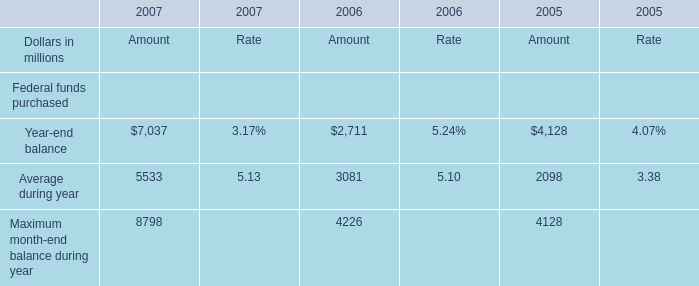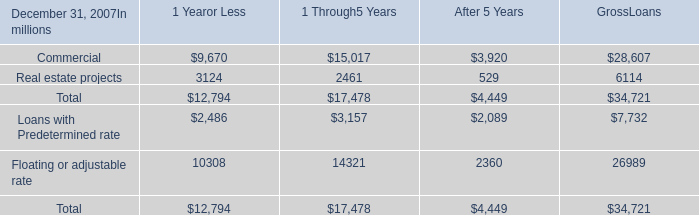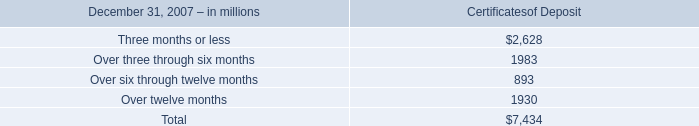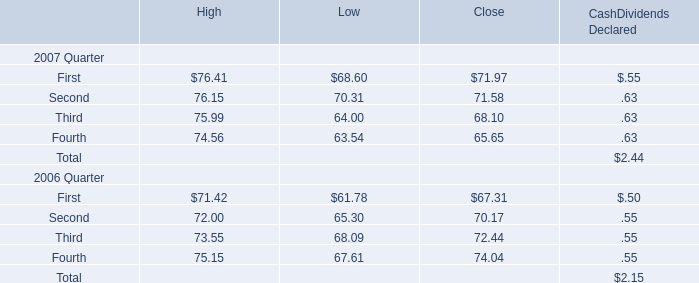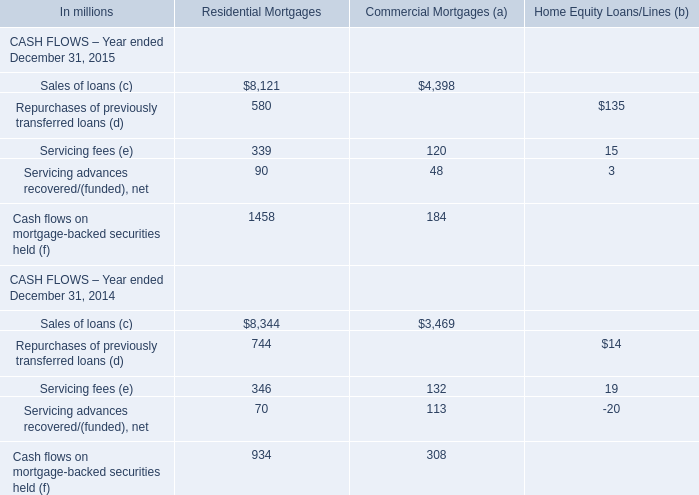What is the value of the Certificates of Deposit for Over three through six months at December 31, 2007? (in million) 
Answer: 1983. 